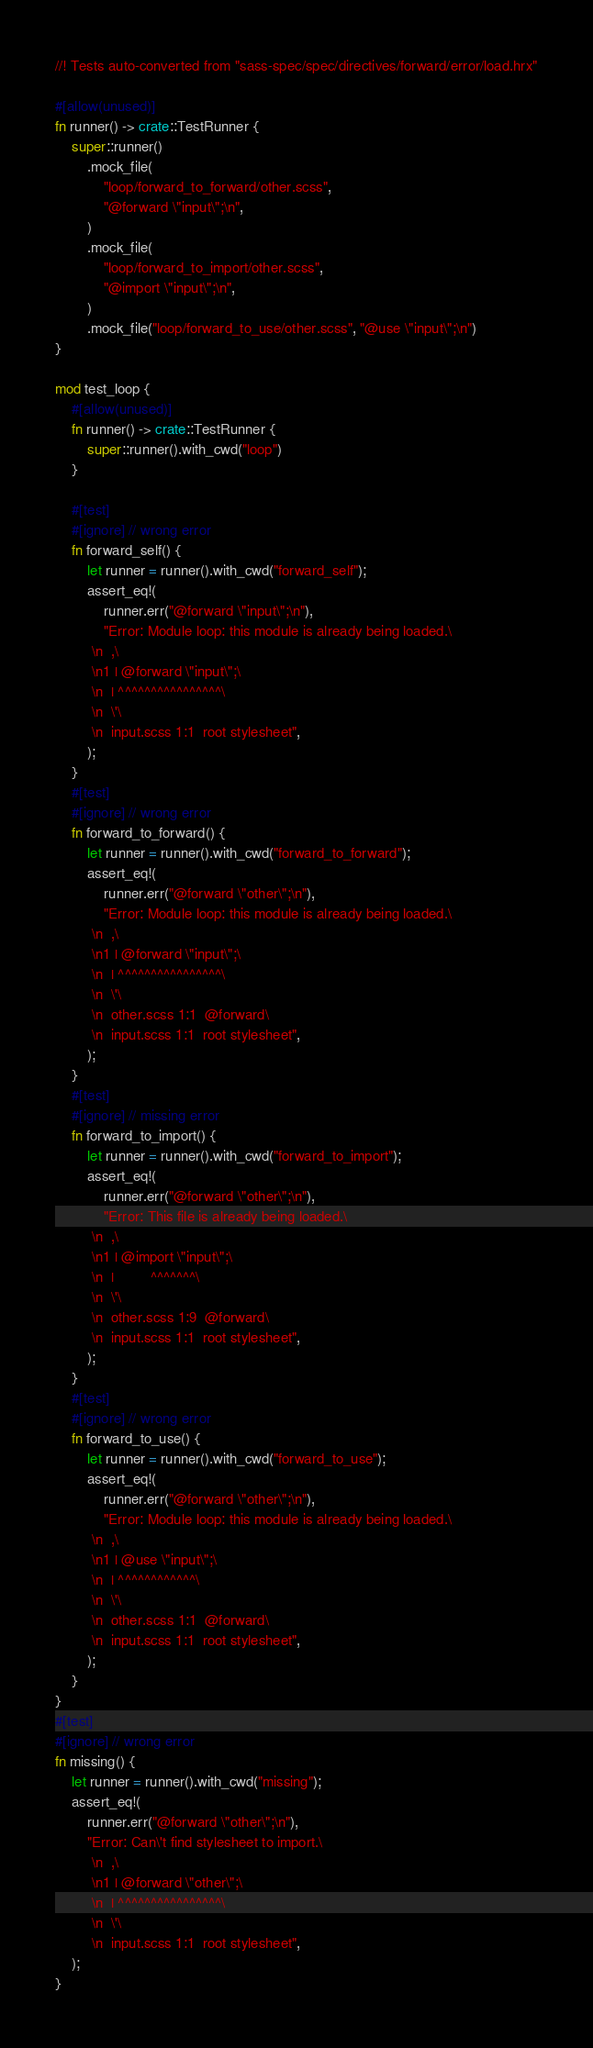<code> <loc_0><loc_0><loc_500><loc_500><_Rust_>//! Tests auto-converted from "sass-spec/spec/directives/forward/error/load.hrx"

#[allow(unused)]
fn runner() -> crate::TestRunner {
    super::runner()
        .mock_file(
            "loop/forward_to_forward/other.scss",
            "@forward \"input\";\n",
        )
        .mock_file(
            "loop/forward_to_import/other.scss",
            "@import \"input\";\n",
        )
        .mock_file("loop/forward_to_use/other.scss", "@use \"input\";\n")
}

mod test_loop {
    #[allow(unused)]
    fn runner() -> crate::TestRunner {
        super::runner().with_cwd("loop")
    }

    #[test]
    #[ignore] // wrong error
    fn forward_self() {
        let runner = runner().with_cwd("forward_self");
        assert_eq!(
            runner.err("@forward \"input\";\n"),
            "Error: Module loop: this module is already being loaded.\
         \n  ,\
         \n1 | @forward \"input\";\
         \n  | ^^^^^^^^^^^^^^^^\
         \n  \'\
         \n  input.scss 1:1  root stylesheet",
        );
    }
    #[test]
    #[ignore] // wrong error
    fn forward_to_forward() {
        let runner = runner().with_cwd("forward_to_forward");
        assert_eq!(
            runner.err("@forward \"other\";\n"),
            "Error: Module loop: this module is already being loaded.\
         \n  ,\
         \n1 | @forward \"input\";\
         \n  | ^^^^^^^^^^^^^^^^\
         \n  \'\
         \n  other.scss 1:1  @forward\
         \n  input.scss 1:1  root stylesheet",
        );
    }
    #[test]
    #[ignore] // missing error
    fn forward_to_import() {
        let runner = runner().with_cwd("forward_to_import");
        assert_eq!(
            runner.err("@forward \"other\";\n"),
            "Error: This file is already being loaded.\
         \n  ,\
         \n1 | @import \"input\";\
         \n  |         ^^^^^^^\
         \n  \'\
         \n  other.scss 1:9  @forward\
         \n  input.scss 1:1  root stylesheet",
        );
    }
    #[test]
    #[ignore] // wrong error
    fn forward_to_use() {
        let runner = runner().with_cwd("forward_to_use");
        assert_eq!(
            runner.err("@forward \"other\";\n"),
            "Error: Module loop: this module is already being loaded.\
         \n  ,\
         \n1 | @use \"input\";\
         \n  | ^^^^^^^^^^^^\
         \n  \'\
         \n  other.scss 1:1  @forward\
         \n  input.scss 1:1  root stylesheet",
        );
    }
}
#[test]
#[ignore] // wrong error
fn missing() {
    let runner = runner().with_cwd("missing");
    assert_eq!(
        runner.err("@forward \"other\";\n"),
        "Error: Can\'t find stylesheet to import.\
         \n  ,\
         \n1 | @forward \"other\";\
         \n  | ^^^^^^^^^^^^^^^^\
         \n  \'\
         \n  input.scss 1:1  root stylesheet",
    );
}
</code> 